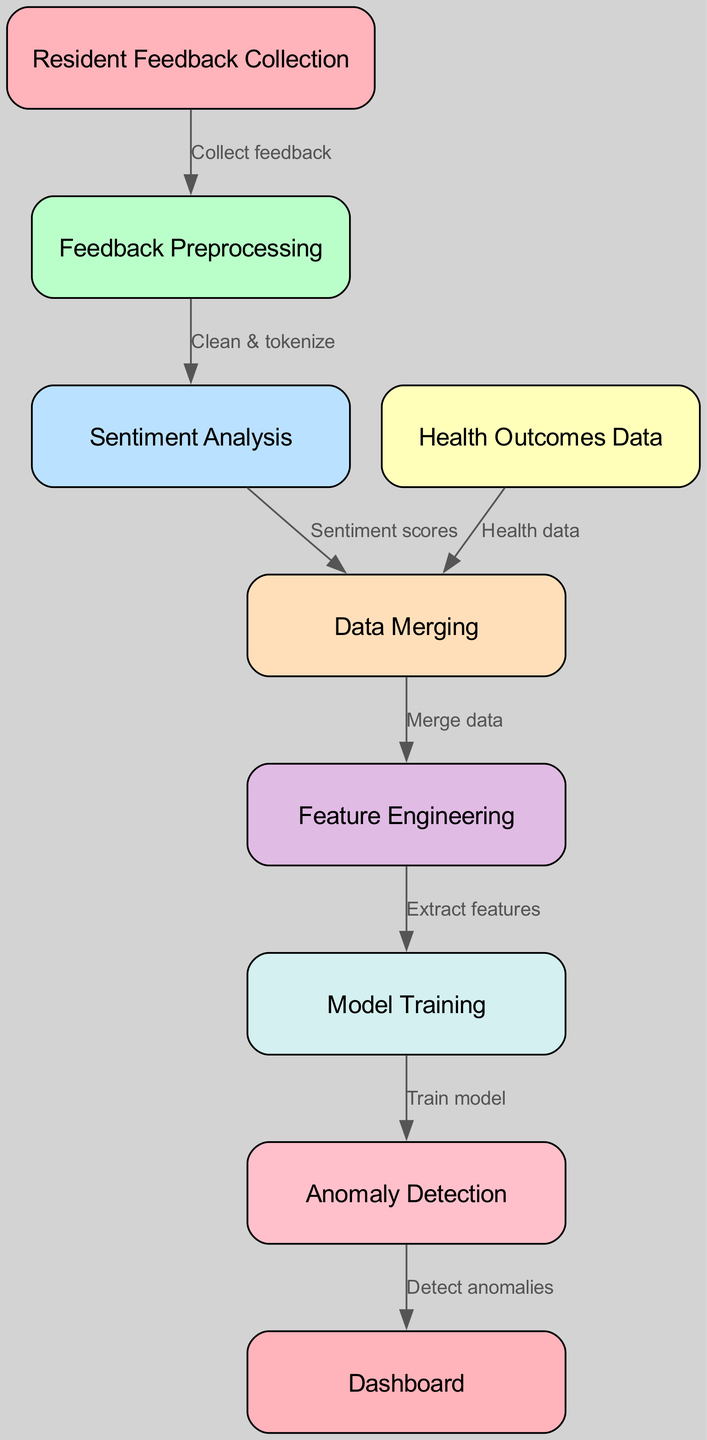how many nodes are in the diagram? The diagram contains several distinct components represented by nodes. By counting each node listed in the data, there are a total of eight unique nodes.
Answer: eight what is the first step in the process? The first step in the process is highlighted as "Resident Feedback Collection". This node indicates where the flow initiates.
Answer: Resident Feedback Collection which node follows "Feedback Preprocessing"? The node directly connected to "Feedback Preprocessing" in the diagram is "Sentiment Analysis". This indicates the next stage of the process after preprocessing.
Answer: Sentiment Analysis what is the relationship between "Health Outcomes Data" and "Data Merging"? The relationship is that "Health Outcomes Data" provides health data that is merged into "Data Merging". This connection indicates a flow of information from health outcomes to the merging stage.
Answer: Health data what type of model is created in the "Model Training" node? In the "Model Training" node, a model is trained as a part of the machine learning process, using the features extracted in the previous step.
Answer: model what happens after "Anomaly Detection"? After "Anomaly Detection", the final output is represented in the "Dashboard". This is where the results of the anomaly detection are visualized or monitored.
Answer: Dashboard which node is responsible for generating sentiment scores? The node responsible for generating the sentiment scores is "Sentiment Analysis". This indicates the point in the diagram where sentiment is quantified.
Answer: Sentiment Analysis what is extracted during "Feature Engineering"? During "Feature Engineering", features are extracted from the merged data. This step is crucial for preparing the data for model training.
Answer: features which node acts as the connection point for the merging of data? The connection point for merging data is the "Data Merging" node. It combines the sentiment scores from the sentiment analysis with health data.
Answer: Data Merging 